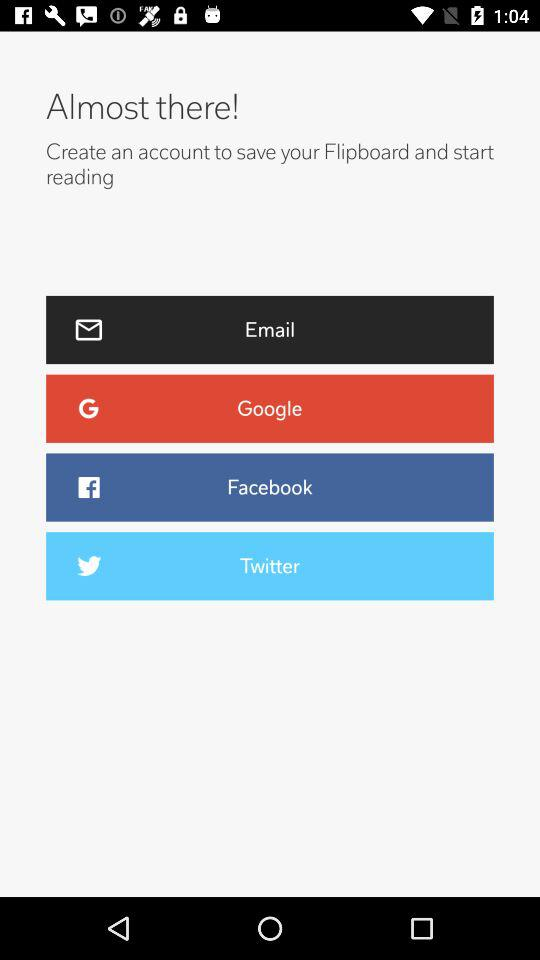What are the options to create an account? The options are "Email", "Google", "Facebook" and "Twitter". 